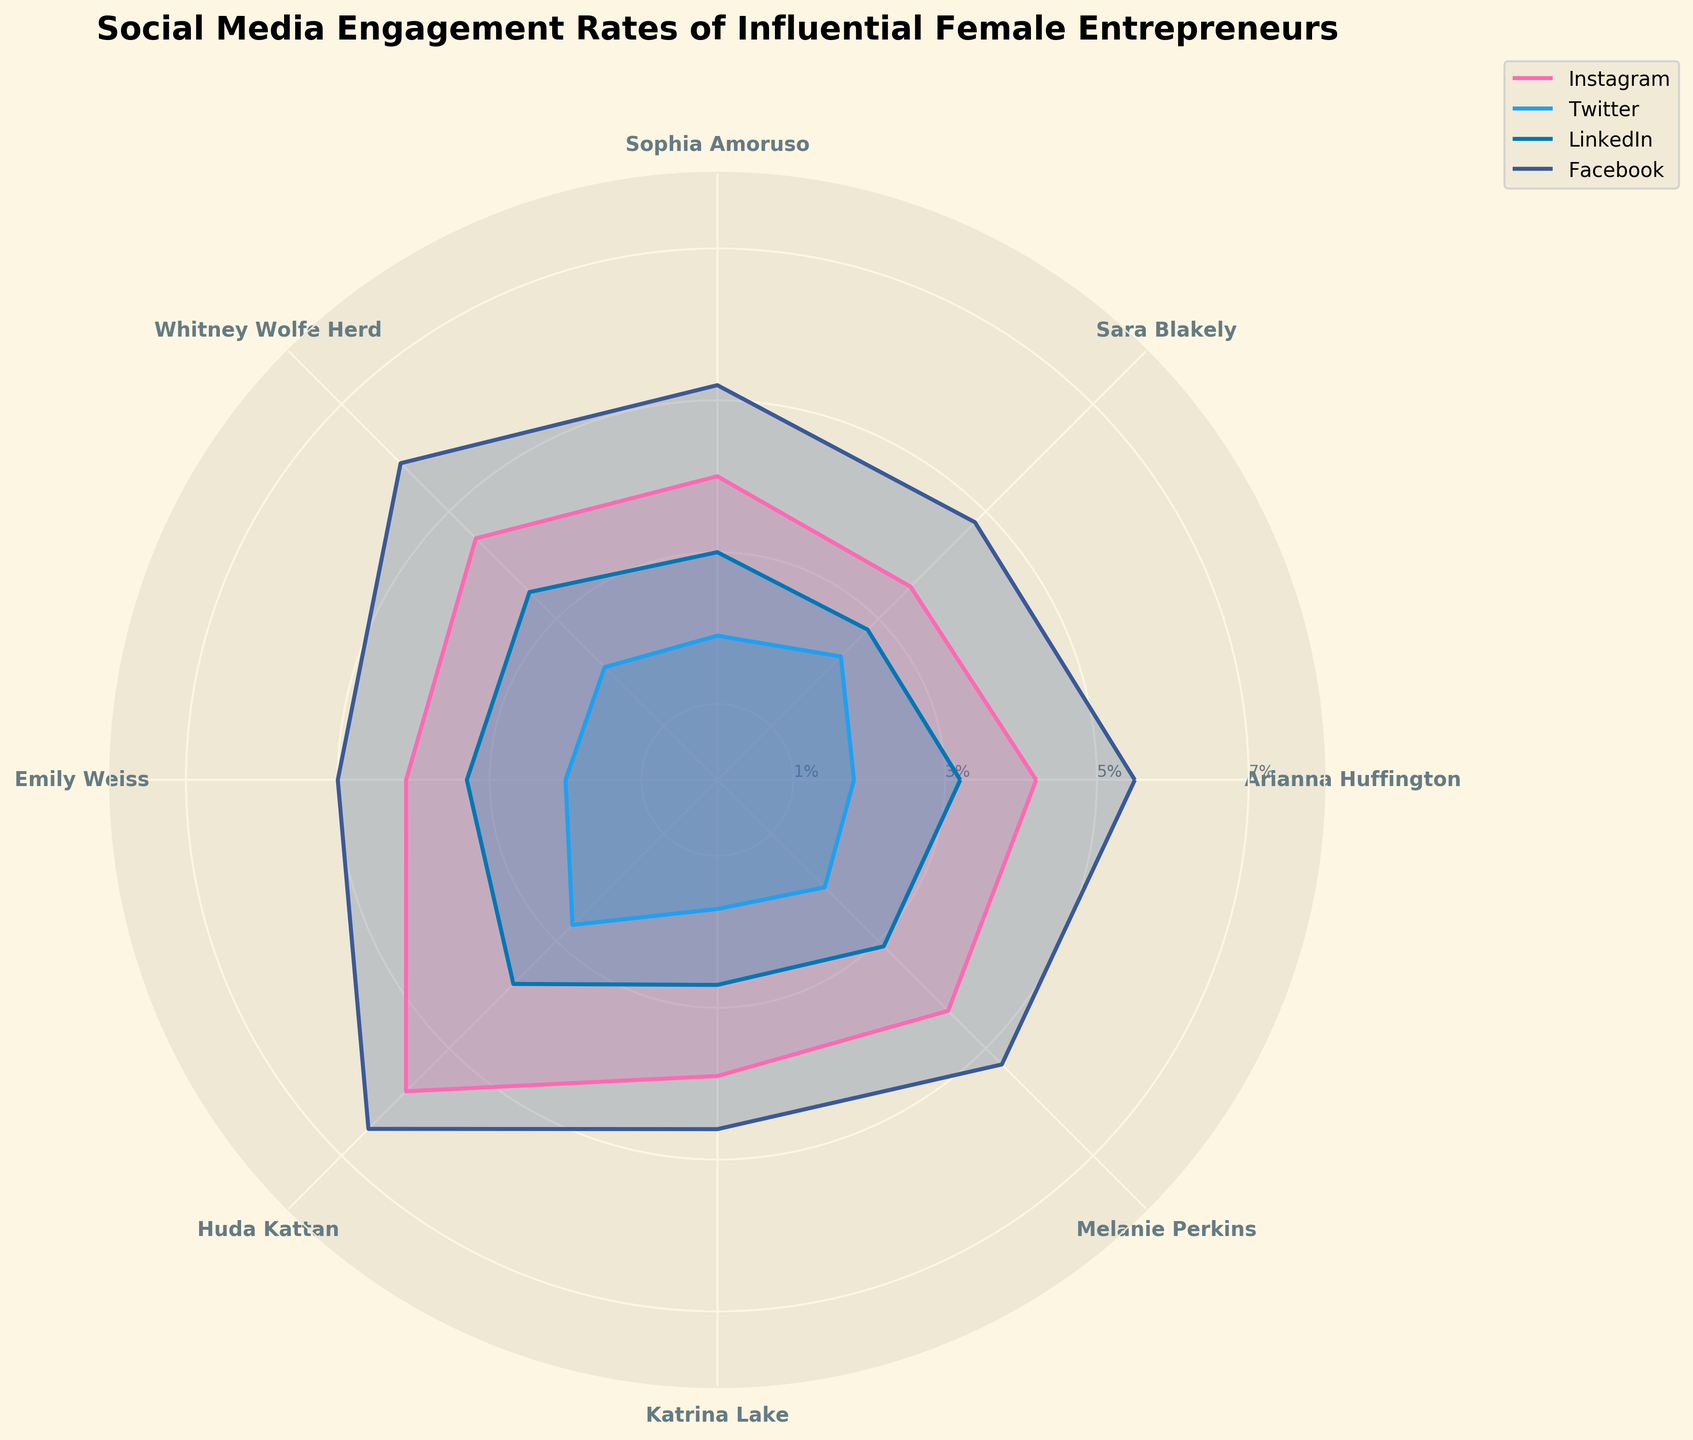What is the title of the chart? The title is shown at the top of the chart and indicates its main topic. "Social Media Engagement Rates of Influential Female Entrepreneurs" is written in bold and larger font size, serving as the header for the plot.
Answer: Social Media Engagement Rates of Influential Female Entrepreneurs How many platforms are compared in the chart? The legend of the chart shows four different colors and labels representing different platforms. These platforms are Instagram, Twitter, LinkedIn, and Facebook.
Answer: Four Which female entrepreneur has the highest Instagram engagement rate? By examining the rose chart, we can compare the lengths of the segments corresponding to Instagram for each individual. Huda Kattan's segment is the longest for Instagram.
Answer: Huda Kattan What is the average LinkedIn engagement rate of the female entrepreneurs? To find the average, add all LinkedIn engagement rates and divide by the total number of entrepreneurs. (3.2 + 2.8 + 3.0 + 3.5 + 3.3 + 3.8 + 2.7 + 3.1) / 8 = 25.4/8 = 3.175
Answer: 3.175 Which platform has the lowest engagement rate for Katrina Lake? By looking at the segments for Katrina Lake, we find that the shortest segment corresponds to Twitter.
Answer: Twitter How does Arianna Huffington's Facebook engagement rate compare to her Instagram engagement rate? Arianna Huffington's Facebook engagement rate is 5.5%, and her Instagram engagement rate is 4.2%. Facebook's rate is higher.
Answer: Facebook's rate is higher Who has a higher engagement rate on Twitter, Sara Blakely or Emily Weiss? By comparing the Twitter segments for Sara Blakely (2.3%) and Emily Weiss (2.0%), Sara Blakely has a slightly higher engagement rate.
Answer: Sara Blakely What is the difference between Huda Kattan's Facebook engagement rate and Melanie Perkins' Instagram engagement rate? Huda Kattan's Facebook engagement rate is 6.5%, and Melanie Perkins' Instagram engagement rate is 4.3%. The difference is 6.5 - 4.3 = 2.2%.
Answer: 2.2% Which platform shows the largest variability in engagement rates among the listed entrepreneurs? By assessing the charts, Facebook has the most significant spread from 4.6% (Katrina Lake) to 6.5% (Huda Kattan), suggesting the largest variability.
Answer: Facebook 